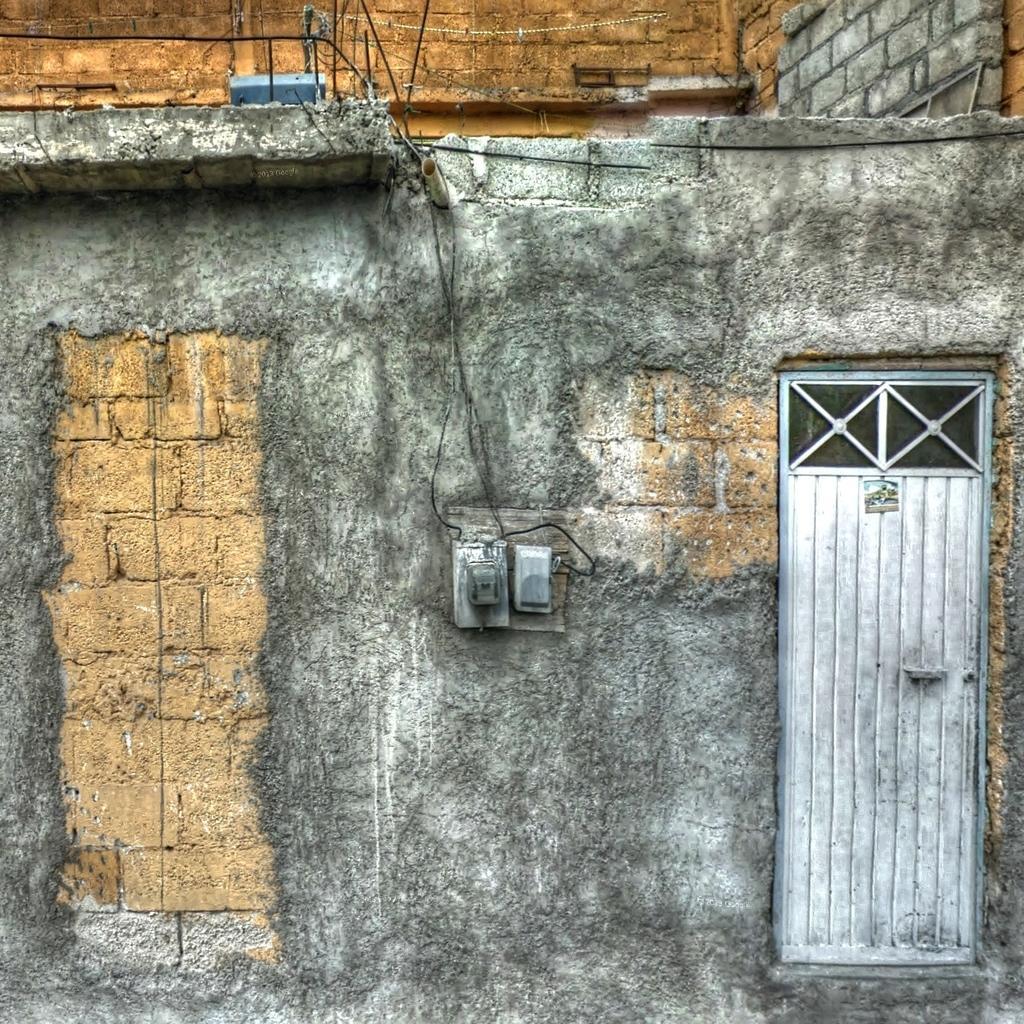Please provide a concise description of this image. In the center of the image there is a power switch board. On the right side of the image we can see a door on the wall. In the background there is a building. 